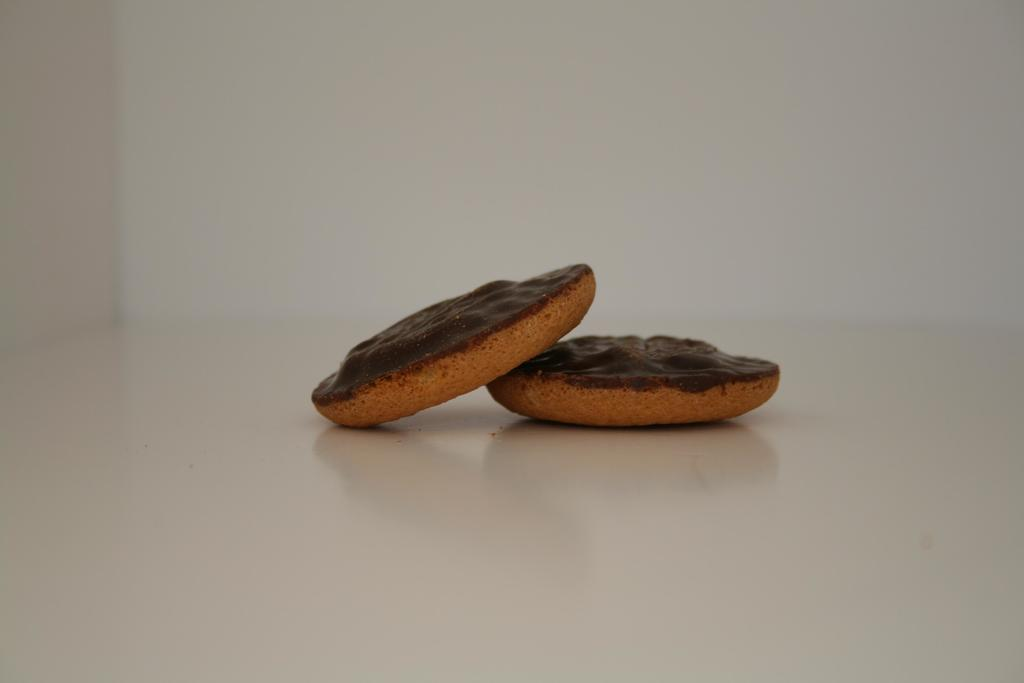What type of food can be seen in the image? There are biscuits in the image. Where are the biscuits located? The biscuits are on a platform. What type of juice is being served with the biscuits in the image? There is no juice present in the image; it only features biscuits on a platform. 